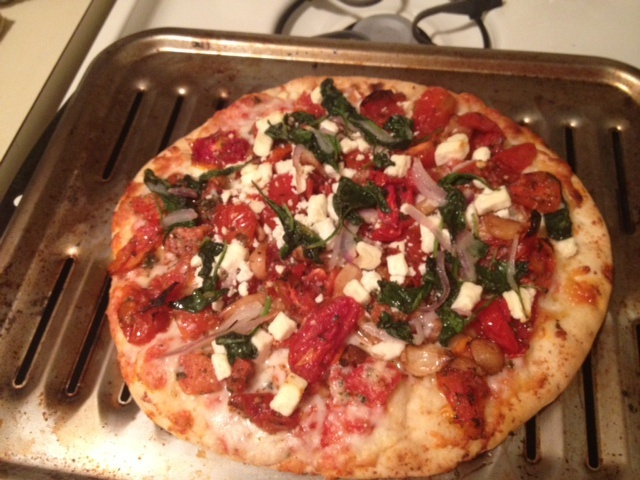Describe the objects in this image and their specific colors. I can see a pizza in gray, brown, tan, and maroon tones in this image. 